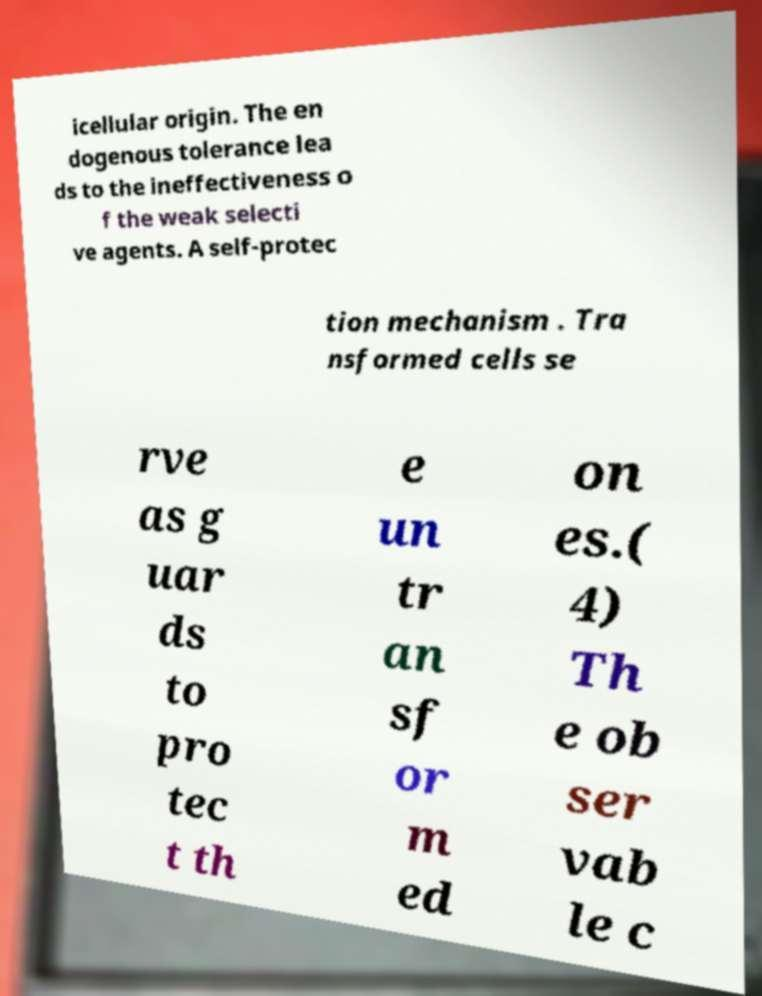Could you extract and type out the text from this image? icellular origin. The en dogenous tolerance lea ds to the ineffectiveness o f the weak selecti ve agents. A self-protec tion mechanism . Tra nsformed cells se rve as g uar ds to pro tec t th e un tr an sf or m ed on es.( 4) Th e ob ser vab le c 